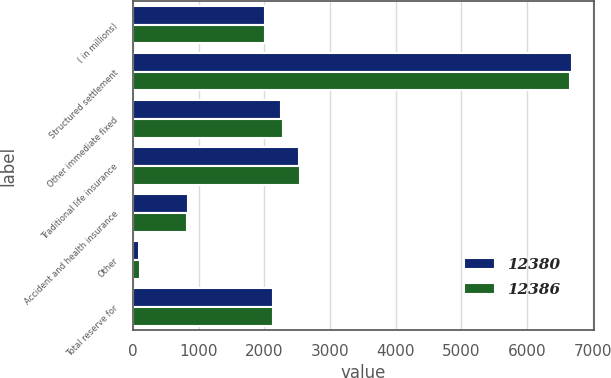Convert chart. <chart><loc_0><loc_0><loc_500><loc_500><stacked_bar_chart><ecel><fcel>( in millions)<fcel>Structured settlement<fcel>Other immediate fixed<fcel>Traditional life insurance<fcel>Accident and health insurance<fcel>Other<fcel>Total reserve for<nl><fcel>12380<fcel>2014<fcel>6682<fcel>2250<fcel>2521<fcel>830<fcel>97<fcel>2132<nl><fcel>12386<fcel>2013<fcel>6645<fcel>2283<fcel>2542<fcel>816<fcel>100<fcel>2132<nl></chart> 